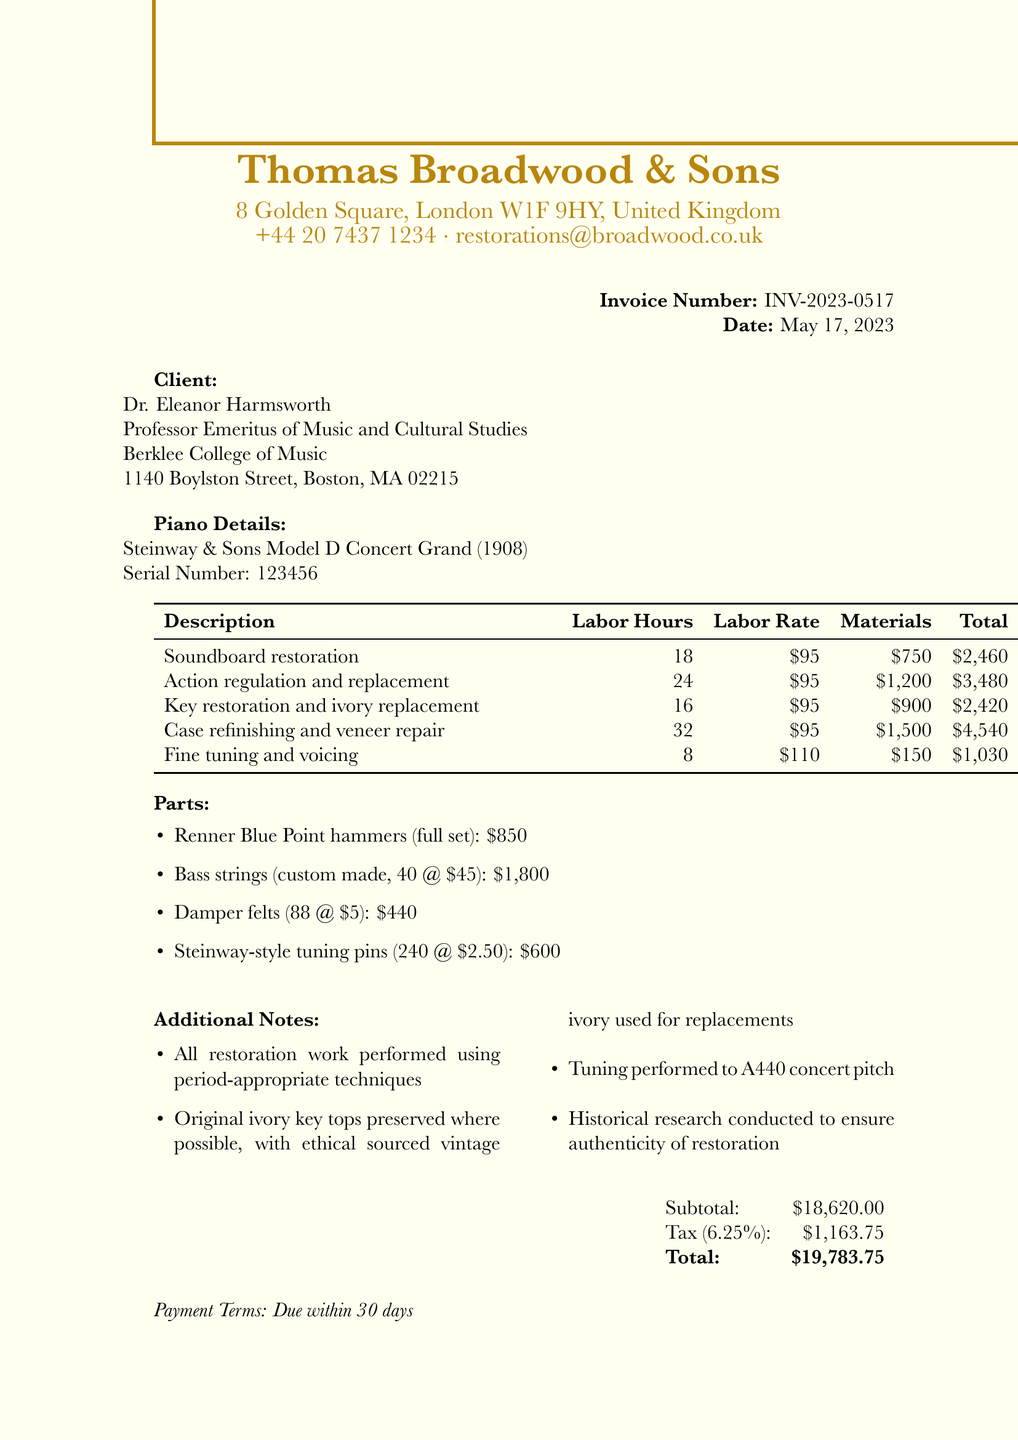What is the invoice number? The invoice number is specifically listed in the document as the unique identifier for this transaction.
Answer: INV-2023-0517 Who is the client? The client's name and title are mentioned at the beginning of the document, indicating the person responsible for this invoice.
Answer: Dr. Eleanor Harmsworth What is the total amount due? The total amount is provided in the summary section at the end of the document, which encapsulates all costs involved.
Answer: $19,783.75 How many labor hours were spent on action regulation and replacement? The document specifies the labor hours for each service, detailing how much effort was spent on this particular service.
Answer: 24 What type of piano is being restored? The piano details section clearly indicates the make and model of the piano, showcasing its historical significance.
Answer: Steinway & Sons Model D Concert Grand What is the tax rate applied? The tax rate is cited in the financial summary, which informs how tax is calculated from the subtotal amount.
Answer: 6.25% How many bass strings were custom made? A breakdown of the parts lists the specific number of bass strings that were part of the restoration process.
Answer: 40 What is an additional note related to the restoration work? The additional notes section contains several remarks regarding the restoration process, highlighting specific approaches taken.
Answer: All restoration work performed using period-appropriate techniques Who performed the restoration work? Details about the restorer are given in the header section, indicating who was responsible for the restoration of the piano.
Answer: Thomas Broadwood & Sons 